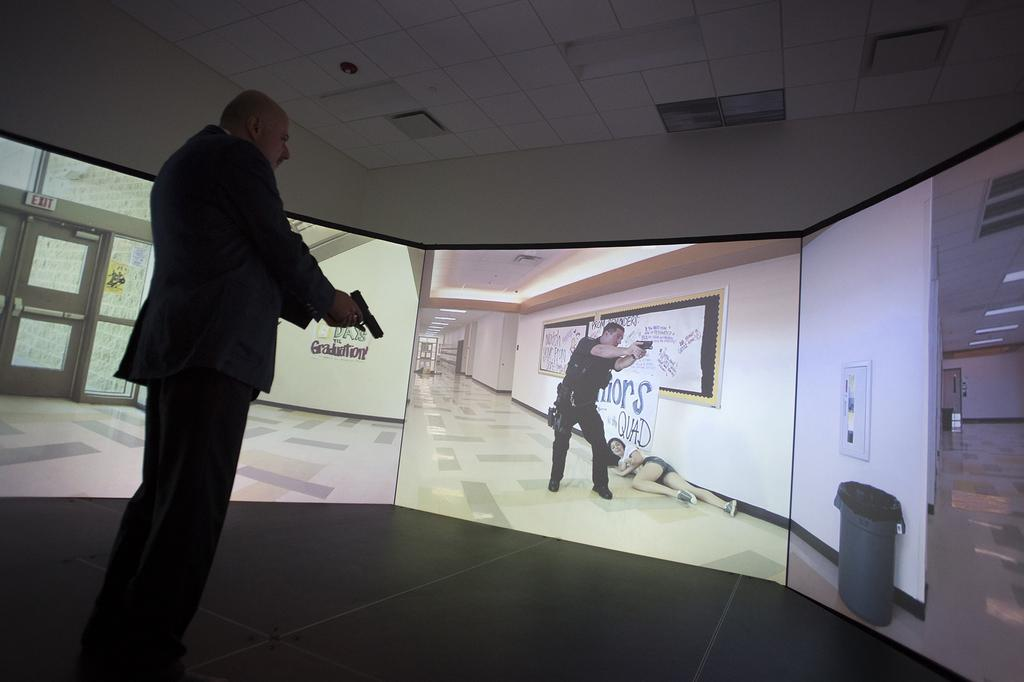Where is the man located in the image? The man is standing in the bottom left corner of the image. What is the man holding in the image? The man is holding a gun in the image. What is in front of the man in the image? There is a screen in front of the man in the image. What can be seen at the top of the image? There is a wall and a ceiling visible at the top of the image. How does the hydrant affect the man's mind in the image? There is no hydrant present in the image, so it cannot affect the man's mind. 